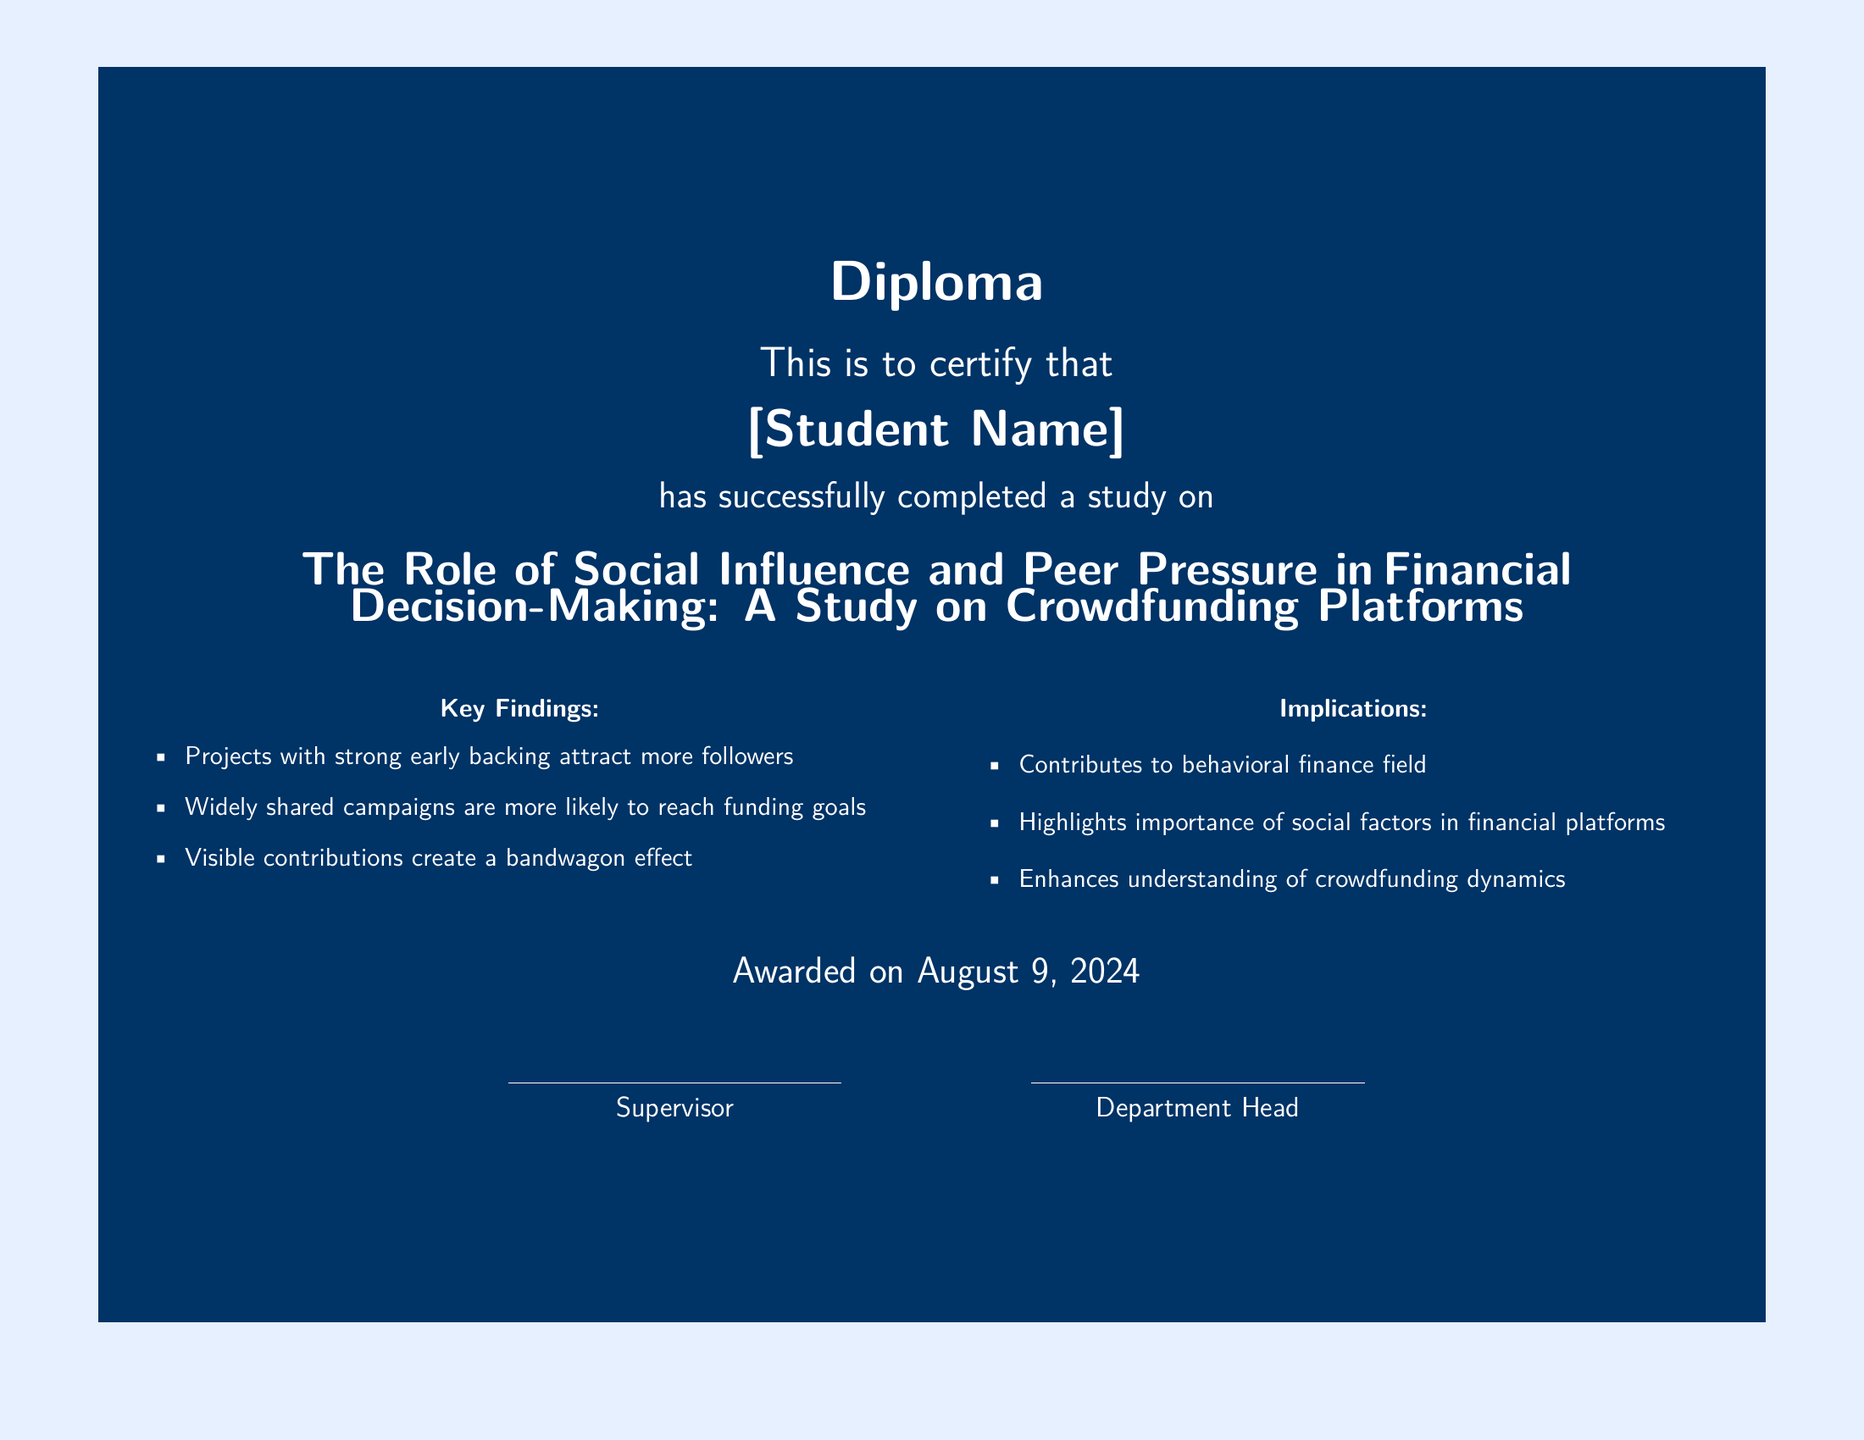What is the title of the study? The title of the study is mentioned prominently in the document, specifically as "The Role of Social Influence and Peer Pressure in Financial Decision-Making: A Study on Crowdfunding Platforms."
Answer: The Role of Social Influence and Peer Pressure in Financial Decision-Making: A Study on Crowdfunding Platforms Who is the student named on the diploma? The name of the student is displayed in the document where it states "[Student Name]."
Answer: [Student Name] What are two key findings mentioned? The document lists specific findings, including "Projects with strong early backing attract more followers" and "Widely shared campaigns are more likely to reach funding goals."
Answer: Projects with strong early backing attract more followers, Widely shared campaigns are more likely to reach funding goals When was the diploma awarded? The award date is indicated at the bottom of the document with the phrase "Awarded on \today," which refers to the current date.
Answer: \today What color is used for the background of the diploma? The background color of the diploma is specifically described as "lightblue" in the document.
Answer: lightblue What is one implication of the study? One of the implications mentioned is that it "Contributes to behavioral finance field."
Answer: Contributes to behavioral finance field Who signs the diploma as the supervisor? The name of the supervisor is represented by a placeholder in the document, which is indicated as "Supervisor."
Answer: Supervisor What is the document type? The document format is clearly identified at the top, which names it as a "Diploma."
Answer: Diploma 